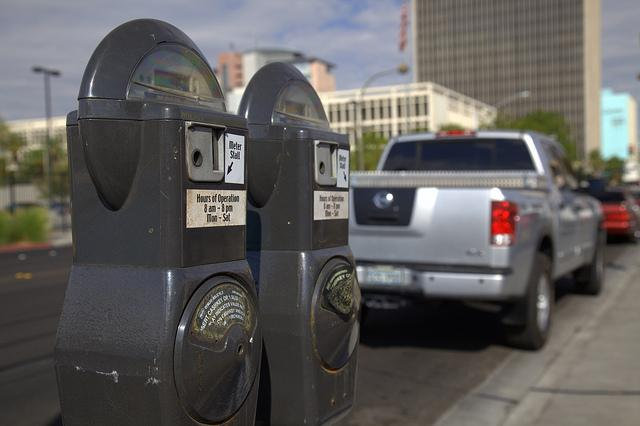What is the purpose of the object? pay parking 